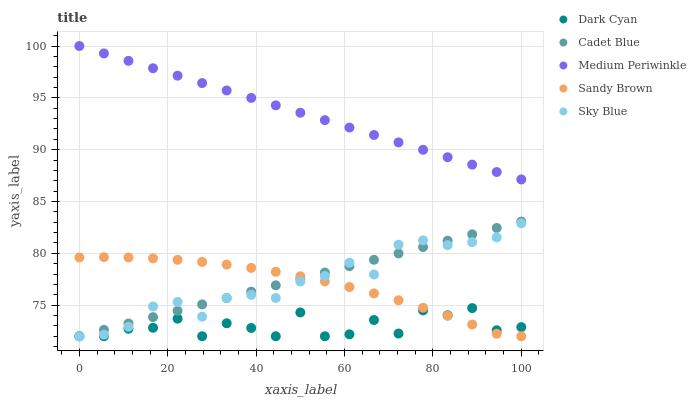Does Dark Cyan have the minimum area under the curve?
Answer yes or no. Yes. Does Medium Periwinkle have the maximum area under the curve?
Answer yes or no. Yes. Does Sandy Brown have the minimum area under the curve?
Answer yes or no. No. Does Sandy Brown have the maximum area under the curve?
Answer yes or no. No. Is Medium Periwinkle the smoothest?
Answer yes or no. Yes. Is Dark Cyan the roughest?
Answer yes or no. Yes. Is Sandy Brown the smoothest?
Answer yes or no. No. Is Sandy Brown the roughest?
Answer yes or no. No. Does Dark Cyan have the lowest value?
Answer yes or no. Yes. Does Medium Periwinkle have the lowest value?
Answer yes or no. No. Does Medium Periwinkle have the highest value?
Answer yes or no. Yes. Does Sandy Brown have the highest value?
Answer yes or no. No. Is Sky Blue less than Medium Periwinkle?
Answer yes or no. Yes. Is Medium Periwinkle greater than Cadet Blue?
Answer yes or no. Yes. Does Sandy Brown intersect Dark Cyan?
Answer yes or no. Yes. Is Sandy Brown less than Dark Cyan?
Answer yes or no. No. Is Sandy Brown greater than Dark Cyan?
Answer yes or no. No. Does Sky Blue intersect Medium Periwinkle?
Answer yes or no. No. 